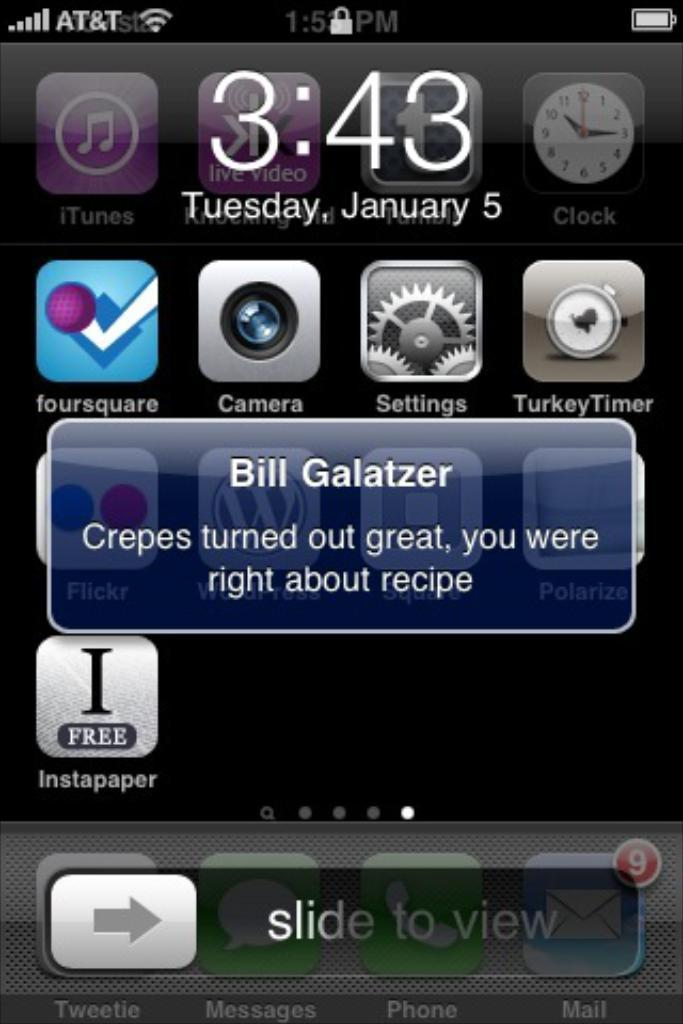<image>
Create a compact narrative representing the image presented. A text message from Bill Galatzer is displayed on a cell phone screen. 